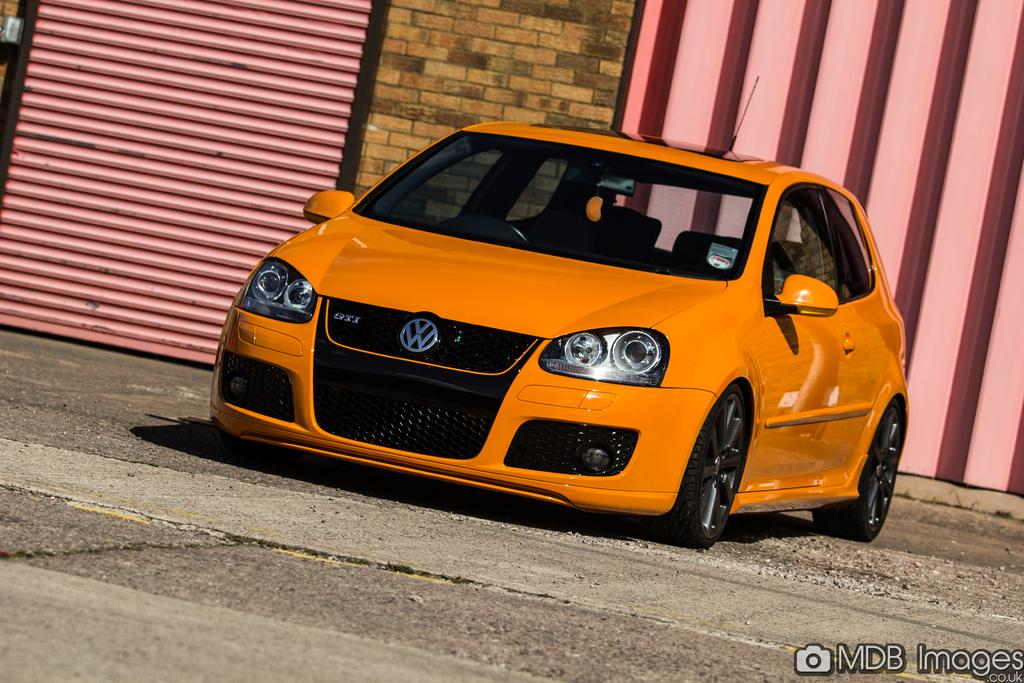What is the main subject of the image? There is a car in the image. What can be seen in the background of the image? There is a shutter and a wall in the background of the image. How many boys are holding a bat in the image? There are no boys or bats present in the image; it features a car and a background with a shutter and a wall. 